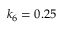<formula> <loc_0><loc_0><loc_500><loc_500>k _ { 6 } = 0 . 2 5</formula> 